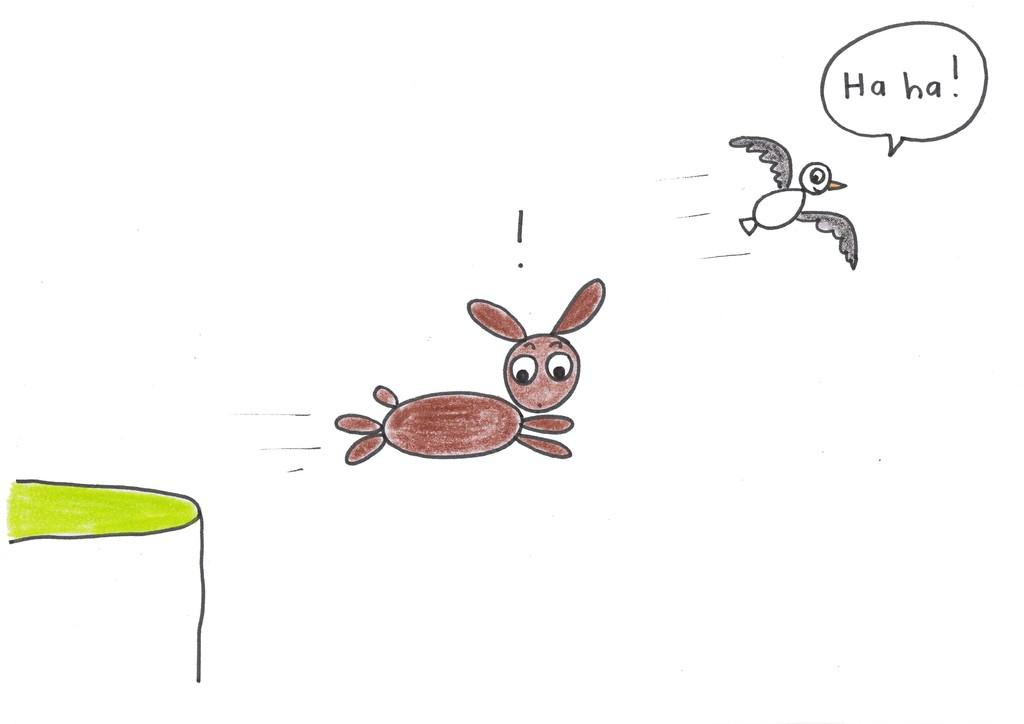What animals are present in the drawing? There is a rabbit and a bird in the drawing. What type of environment is depicted in the drawing? There is grass in the drawing, suggesting a natural setting. How many jellyfish can be seen swimming in the grass in the drawing? There are no jellyfish present in the drawing; it features a rabbit, a bird, and grass. 